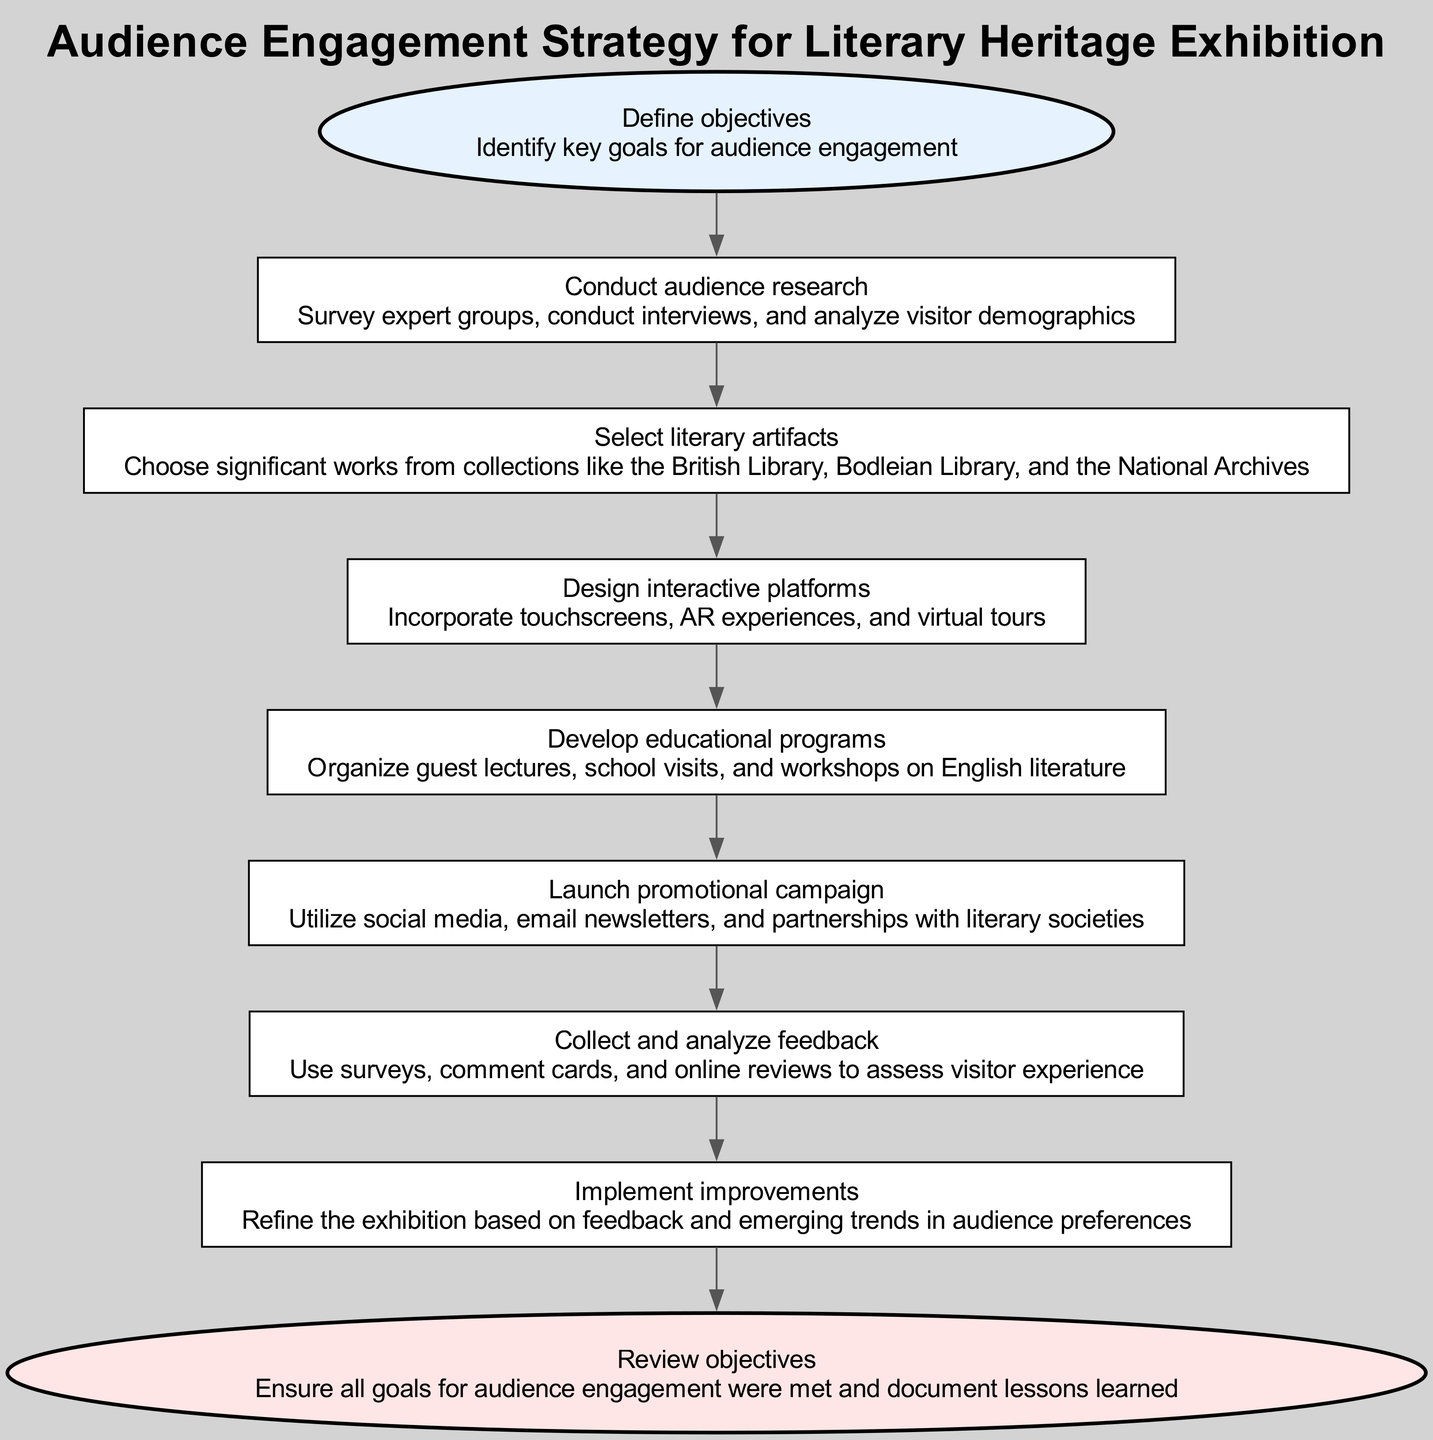What is the first action in the strategy? The first action in the strategy is identified as "Define objectives." This can be found at the starting node labeled "Start."
Answer: Define objectives How many nodes are there in the flowchart? Counting all the individual steps and actions in the flow, there are nine nodes including both the start and end nodes.
Answer: Nine What action follows "Curate Content"? After "Curate Content," the next action in the sequence is "Interact With Audience." This follows directly in the flow.
Answer: Interact With Audience What is the last action before the end of the strategy? The last action before reaching the "End" node is "Continuous Improvement." Examining the flowchart, this action leads directly to the conclusion.
Answer: Continuous Improvement Which node involves audience research? The node that involves audience research is labeled "Identify Target Audience." This is explicitly described in the details of that node.
Answer: Identify Target Audience Which two actions are directly related to improving audience engagement? The two actions that focus on improving audience engagement are "Evaluate Feedback" and "Implement Improvements." These actions are interconnected in the enhancement process.
Answer: Evaluate Feedback, Implement Improvements What type of content is being selected in the "Curate Content" step? The content being selected in the "Curate Content" step involves significant works from collections like the British Library, Bodleian Library, and the National Archives. This is specific to literary artifacts.
Answer: Literary artifacts How is audience interaction designed in this strategy? Audience interaction is designed through actions included in the "Interact With Audience" step, which mentions incorporating touchscreens, AR experiences, and virtual tours to enhance engagement.
Answer: Interactive platforms How does the strategy suggest promoting the exhibition? The strategy suggests promoting the exhibition by launching a promotional campaign, utilizing social media, email newsletters, and partnerships with literary societies. This is directly mentioned in the corresponding action step.
Answer: Promotional campaign 